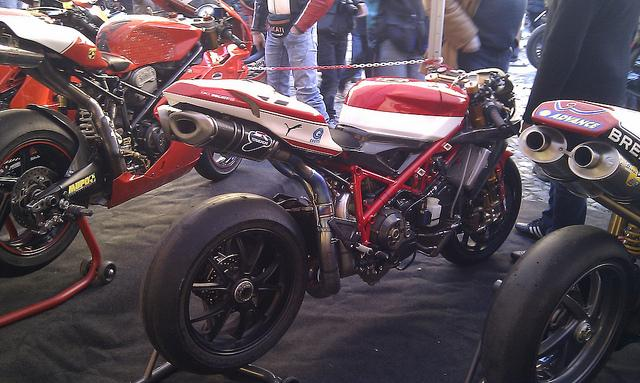What type of vehicle are these? Please explain your reasoning. motorcycle. These motor vehicles have two wheels a seat and handlebars. 